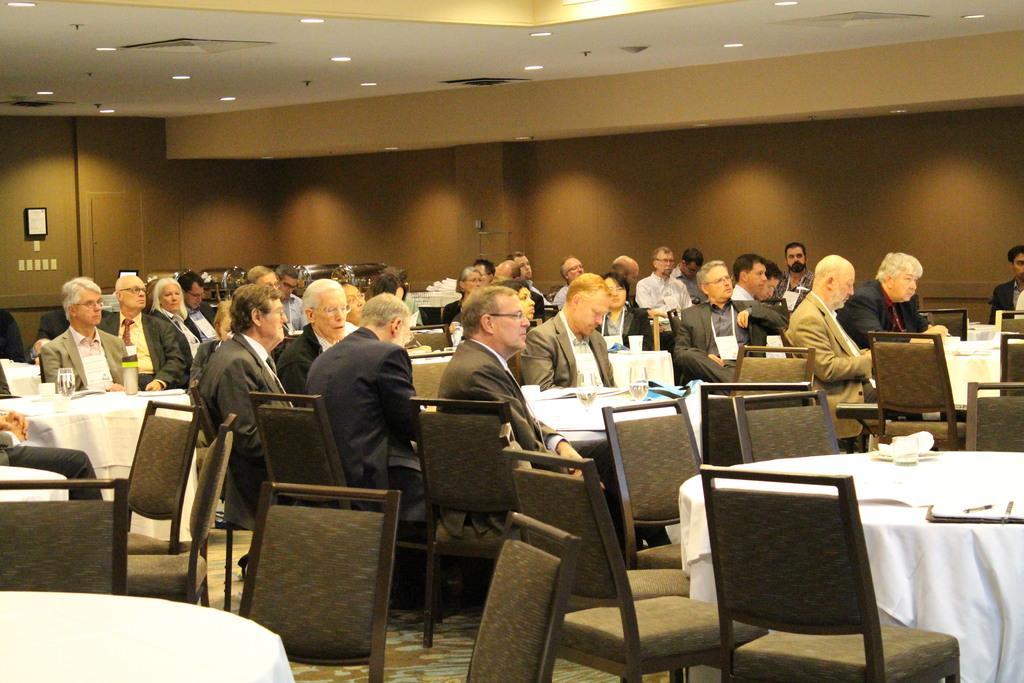Could you give a brief overview of what you see in this image? In this picture we can see a group of people sitting on chair and in front of them there is a table and on table we can see glasses, cloth and in background we can see wall, frame, lights. 